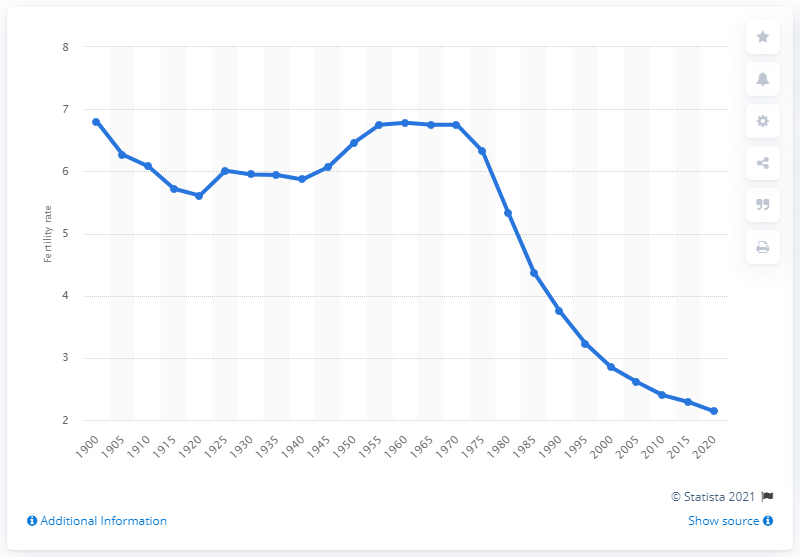Identify some key points in this picture. Mexico's fertility rate dropped to 5.6 in 1920. The fertility rate in Mexico during the 1950s and 1960s was 6.8 children per woman. 